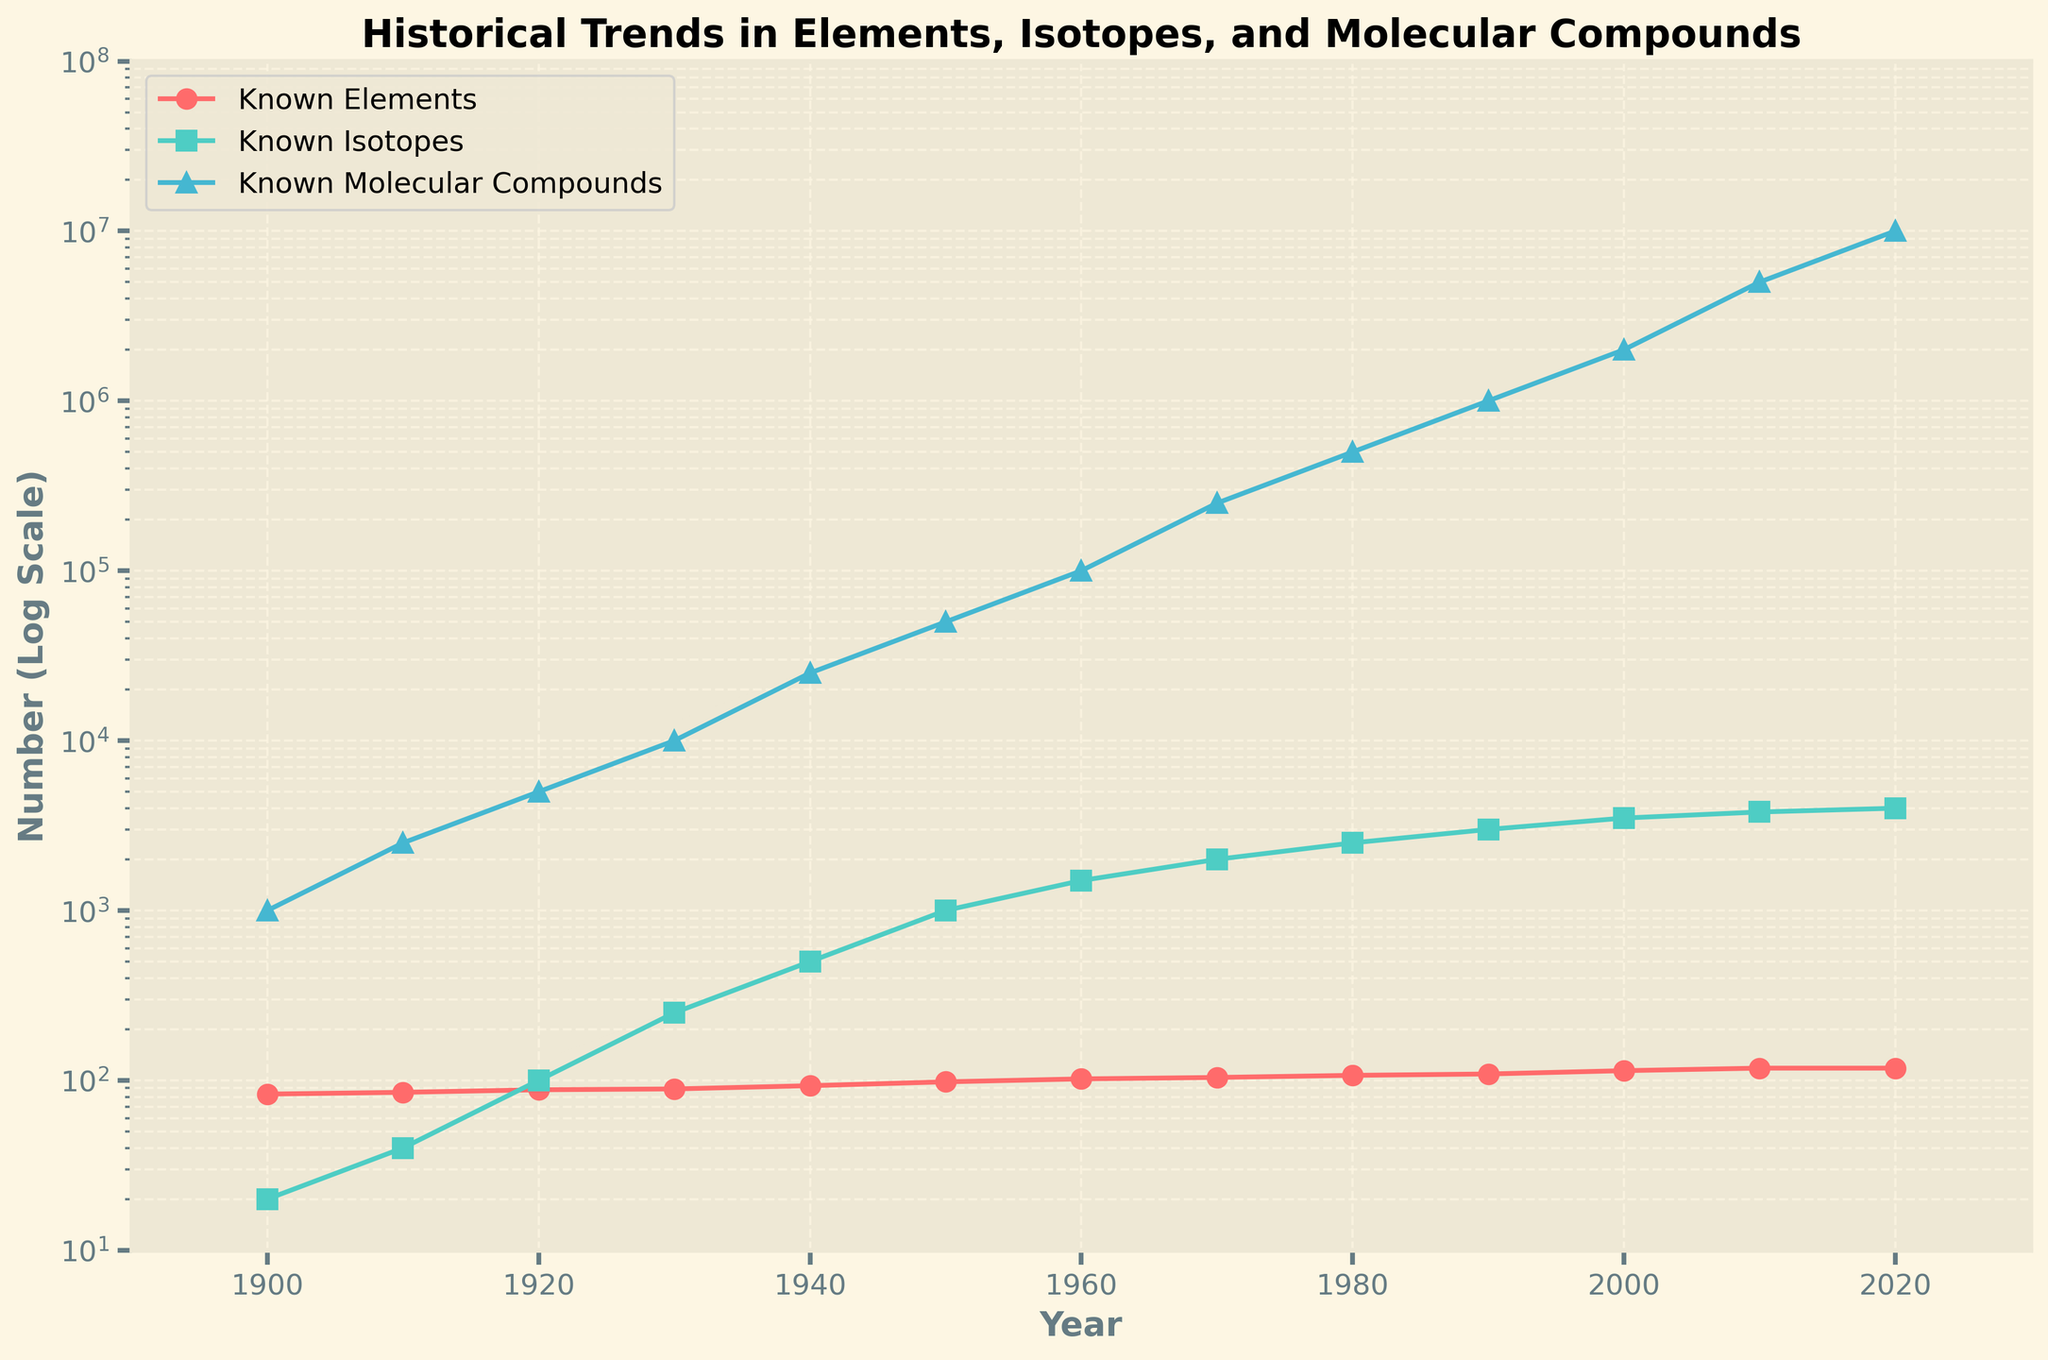What is the general trend in the number of known molecular compounds from 1900 to 2020? Observing the plot, it's apparent that the number of known molecular compounds has been exponentially increasing from 1900 to 2020. The y-axis uses a logarithmic scale, so even though the line may appear somewhat linear, it represents rapid exponential growth.
Answer: Exponential increase How does the growth rate of known elements compare to that of known isotopes between 1900 and 2020? The plot shows that the number of known elements has increased at a much slower rate compared to the number of known isotopes. The line representing isotopes is much steeper, indicating a faster growth rate.
Answer: Known isotopes increased faster In which year did the number of known isotopes first exceed 1000? By examining the green line representing isotopes, the number of known isotopes first exceeds 1000 around the year 1950.
Answer: 1950 How many more known elements were there in 2020 compared to 1900? The number of known elements in 2020 is 118, and in 1900 it was 83. The difference is 118 - 83 = 35.
Answer: 35 What is the approximate doubling period of known molecular compounds between 1950 and 1980? In 1950, there were about 50,000 known molecular compounds, and in 1980 there were about 500,000. Doubling from 50,000 to 100,000 to 200,000 to 400,000 takes approximately three doublings. Since this occurred over approximately 30 years, the doubling period is about 30/3 = 10 years.
Answer: 10 years Which category (elements, isotopes, or molecular compounds) exhibited the most rapid growth visually? The plot indicates that the blue line representing known molecular compounds shows the steepest increase, indicating the most rapid growth over time.
Answer: Molecular compounds Did the number of known elements ever decrease from 1900 to 2020? Observing the red line representing known elements, it is noticeable that the line continually increases or remains flat, indicating there was no decrease in the number of known elements during this period.
Answer: No Between which decades did the number of known isotopes see the largest jump? The green isotope line shows a significant upward jump between 1940 and 1950, where it goes from about 500 to 1000, representing the largest increase in any decade.
Answer: 1940-1950 How many times did the known molecular compounds increase from 1930 to 2020? In 1930, there were about 10,000 known molecular compounds, and in 2020 there were about 10,000,000. The ratio is 10,000,000 / 10,000 = 1000 times.
Answer: 1000 times At what point in time did the number of known elements reach its peak based on the graph, and what was that number? According to the red line in the graph, the number of known elements reached its peak in 2010 and 2020, stabilizing at 118.
Answer: 2010 and 2020, 118 